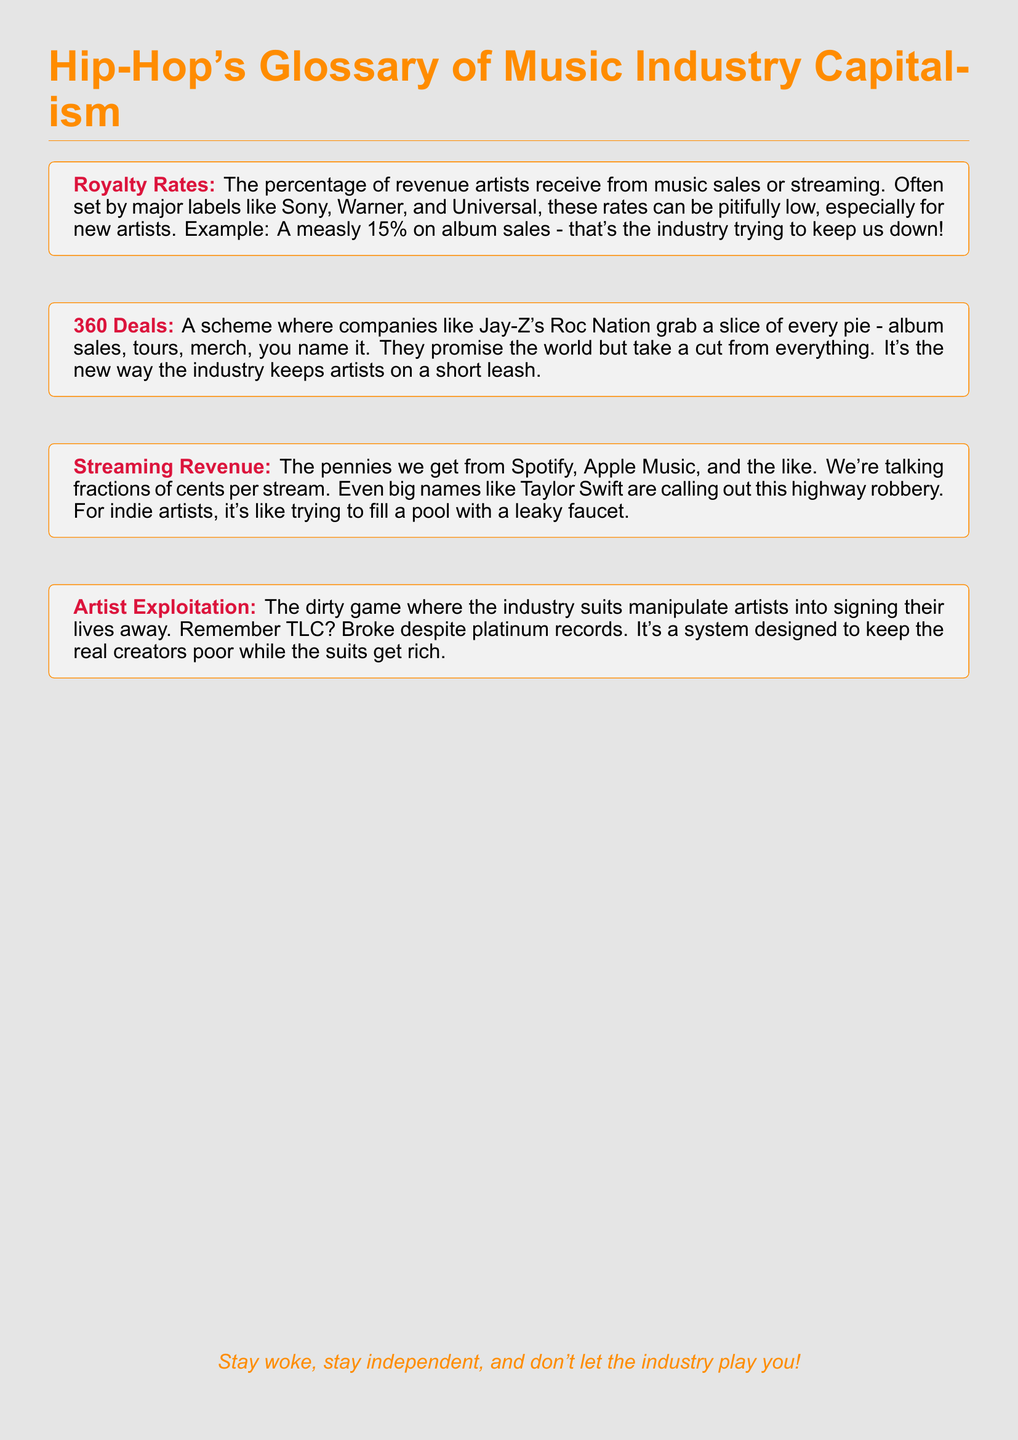What are royalty rates? Royalty rates are the percentage of revenue artists receive from music sales or streaming, set by major labels.
Answer: percentage of revenue What is a 360 deal? A 360 deal is a scheme where companies take a cut from all aspects of an artist's career, like album sales and tours.
Answer: scheme taking a cut What is streaming revenue? Streaming revenue refers to the pennies artists receive from platforms like Spotify and Apple Music for their streams.
Answer: pennies from streams Who are TLC? TLC is an example of an artist group that was exploited in the music industry, being broke despite having platinum records.
Answer: an artist group What does artist exploitation mean? Artist exploitation is the practice where industry executives manipulate artists, often leading to financial struggles despite their success.
Answer: manipulative practice What percentage do artists often receive on album sales? Artists often receive a meager 15% on album sales from major labels, according to the document.
Answer: 15% What is the effect of streaming revenue on indie artists? The document compares streaming revenue for indie artists to filling a pool with a leaky faucet, indicating it is inadequate.
Answer: inadequate revenue What is the document's tone regarding the music industry? The document has a critical tone towards the music industry, particularly regarding capitalism and exploitation.
Answer: critical tone 